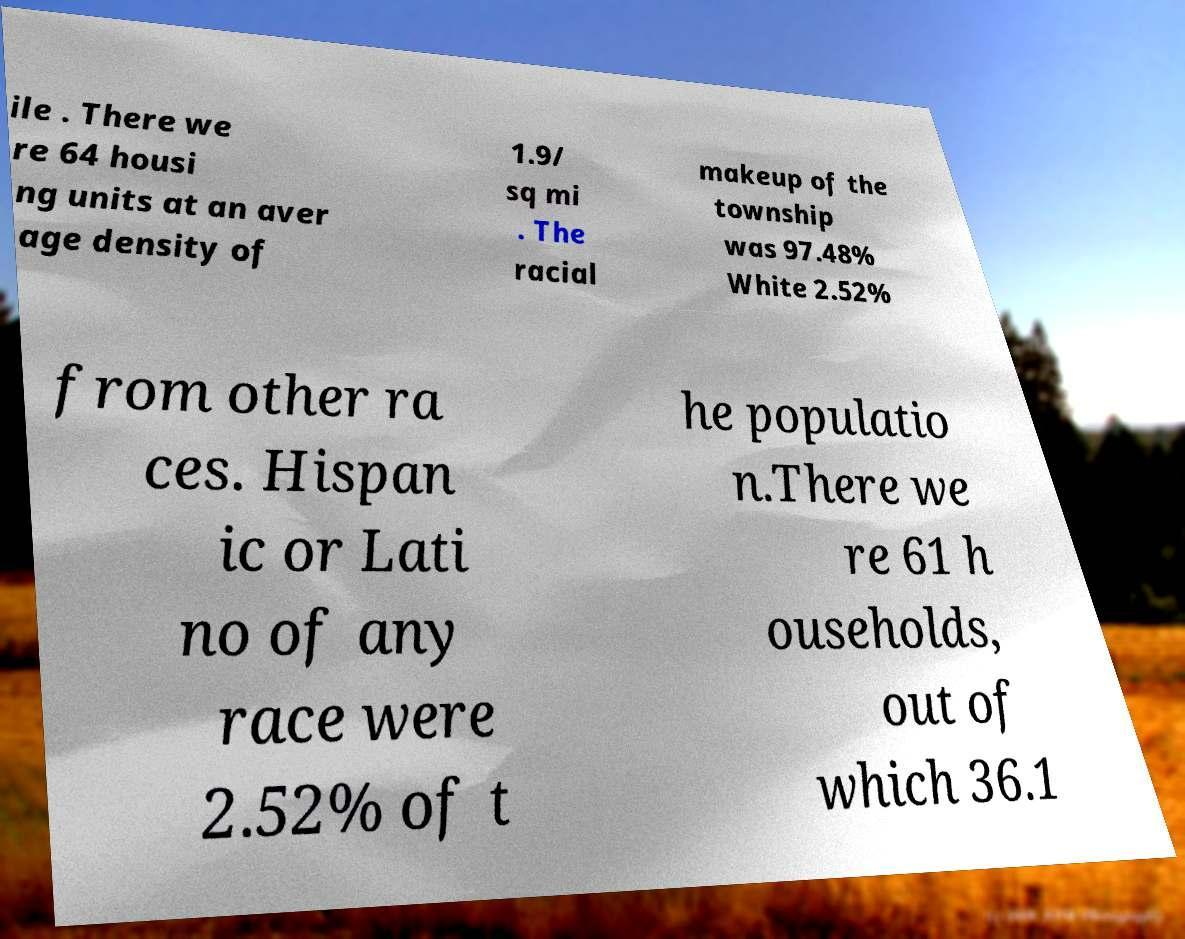Can you accurately transcribe the text from the provided image for me? ile . There we re 64 housi ng units at an aver age density of 1.9/ sq mi . The racial makeup of the township was 97.48% White 2.52% from other ra ces. Hispan ic or Lati no of any race were 2.52% of t he populatio n.There we re 61 h ouseholds, out of which 36.1 